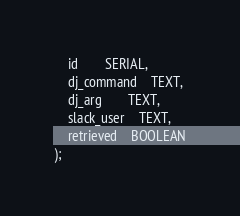Convert code to text. <code><loc_0><loc_0><loc_500><loc_500><_SQL_>	id		SERIAL,
	dj_command	TEXT,
	dj_arg		TEXT,
	slack_user	TEXT,
	retrieved	BOOLEAN
);

</code> 